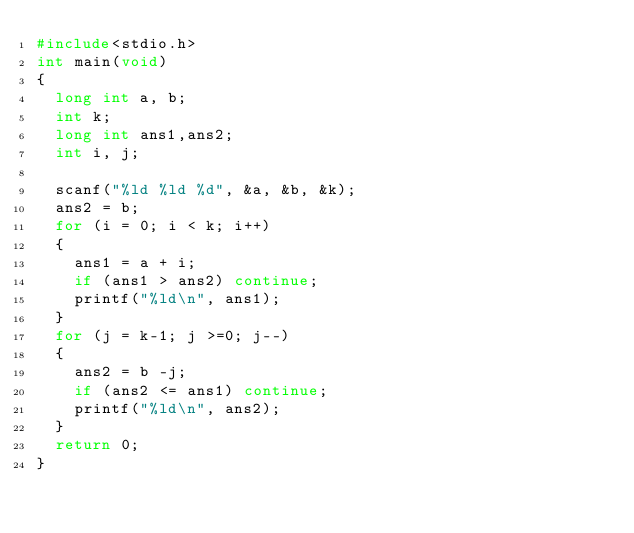<code> <loc_0><loc_0><loc_500><loc_500><_C_>#include<stdio.h>
int main(void)
{
	long int a, b;
	int k;
	long int ans1,ans2;
	int i, j;

	scanf("%ld %ld %d", &a, &b, &k);
	ans2 = b;
	for (i = 0; i < k; i++)
	{
		ans1 = a + i;
		if (ans1 > ans2) continue;
		printf("%ld\n", ans1);
	}
	for (j = k-1; j >=0; j--)
	{
		ans2 = b -j;
		if (ans2 <= ans1) continue;
		printf("%ld\n", ans2);
	}
	return 0;
}</code> 